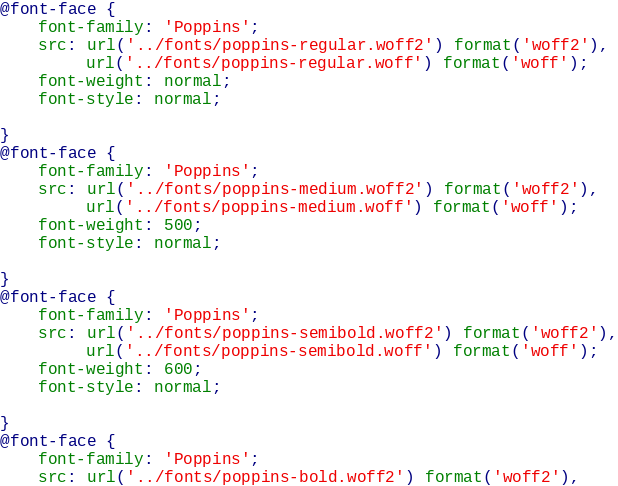Convert code to text. <code><loc_0><loc_0><loc_500><loc_500><_CSS_>@font-face {
    font-family: 'Poppins';
    src: url('../fonts/poppins-regular.woff2') format('woff2'),
         url('../fonts/poppins-regular.woff') format('woff');
    font-weight: normal;
    font-style: normal;

}
@font-face {
    font-family: 'Poppins';
    src: url('../fonts/poppins-medium.woff2') format('woff2'),
         url('../fonts/poppins-medium.woff') format('woff');
    font-weight: 500;
    font-style: normal;

}
@font-face {
    font-family: 'Poppins';
    src: url('../fonts/poppins-semibold.woff2') format('woff2'),
         url('../fonts/poppins-semibold.woff') format('woff');
    font-weight: 600;
    font-style: normal;

}
@font-face {
    font-family: 'Poppins';
    src: url('../fonts/poppins-bold.woff2') format('woff2'),</code> 